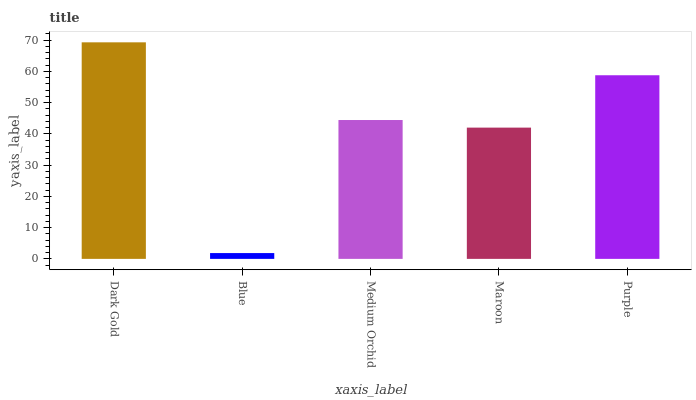Is Blue the minimum?
Answer yes or no. Yes. Is Dark Gold the maximum?
Answer yes or no. Yes. Is Medium Orchid the minimum?
Answer yes or no. No. Is Medium Orchid the maximum?
Answer yes or no. No. Is Medium Orchid greater than Blue?
Answer yes or no. Yes. Is Blue less than Medium Orchid?
Answer yes or no. Yes. Is Blue greater than Medium Orchid?
Answer yes or no. No. Is Medium Orchid less than Blue?
Answer yes or no. No. Is Medium Orchid the high median?
Answer yes or no. Yes. Is Medium Orchid the low median?
Answer yes or no. Yes. Is Blue the high median?
Answer yes or no. No. Is Maroon the low median?
Answer yes or no. No. 